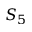Convert formula to latex. <formula><loc_0><loc_0><loc_500><loc_500>S _ { 5 }</formula> 